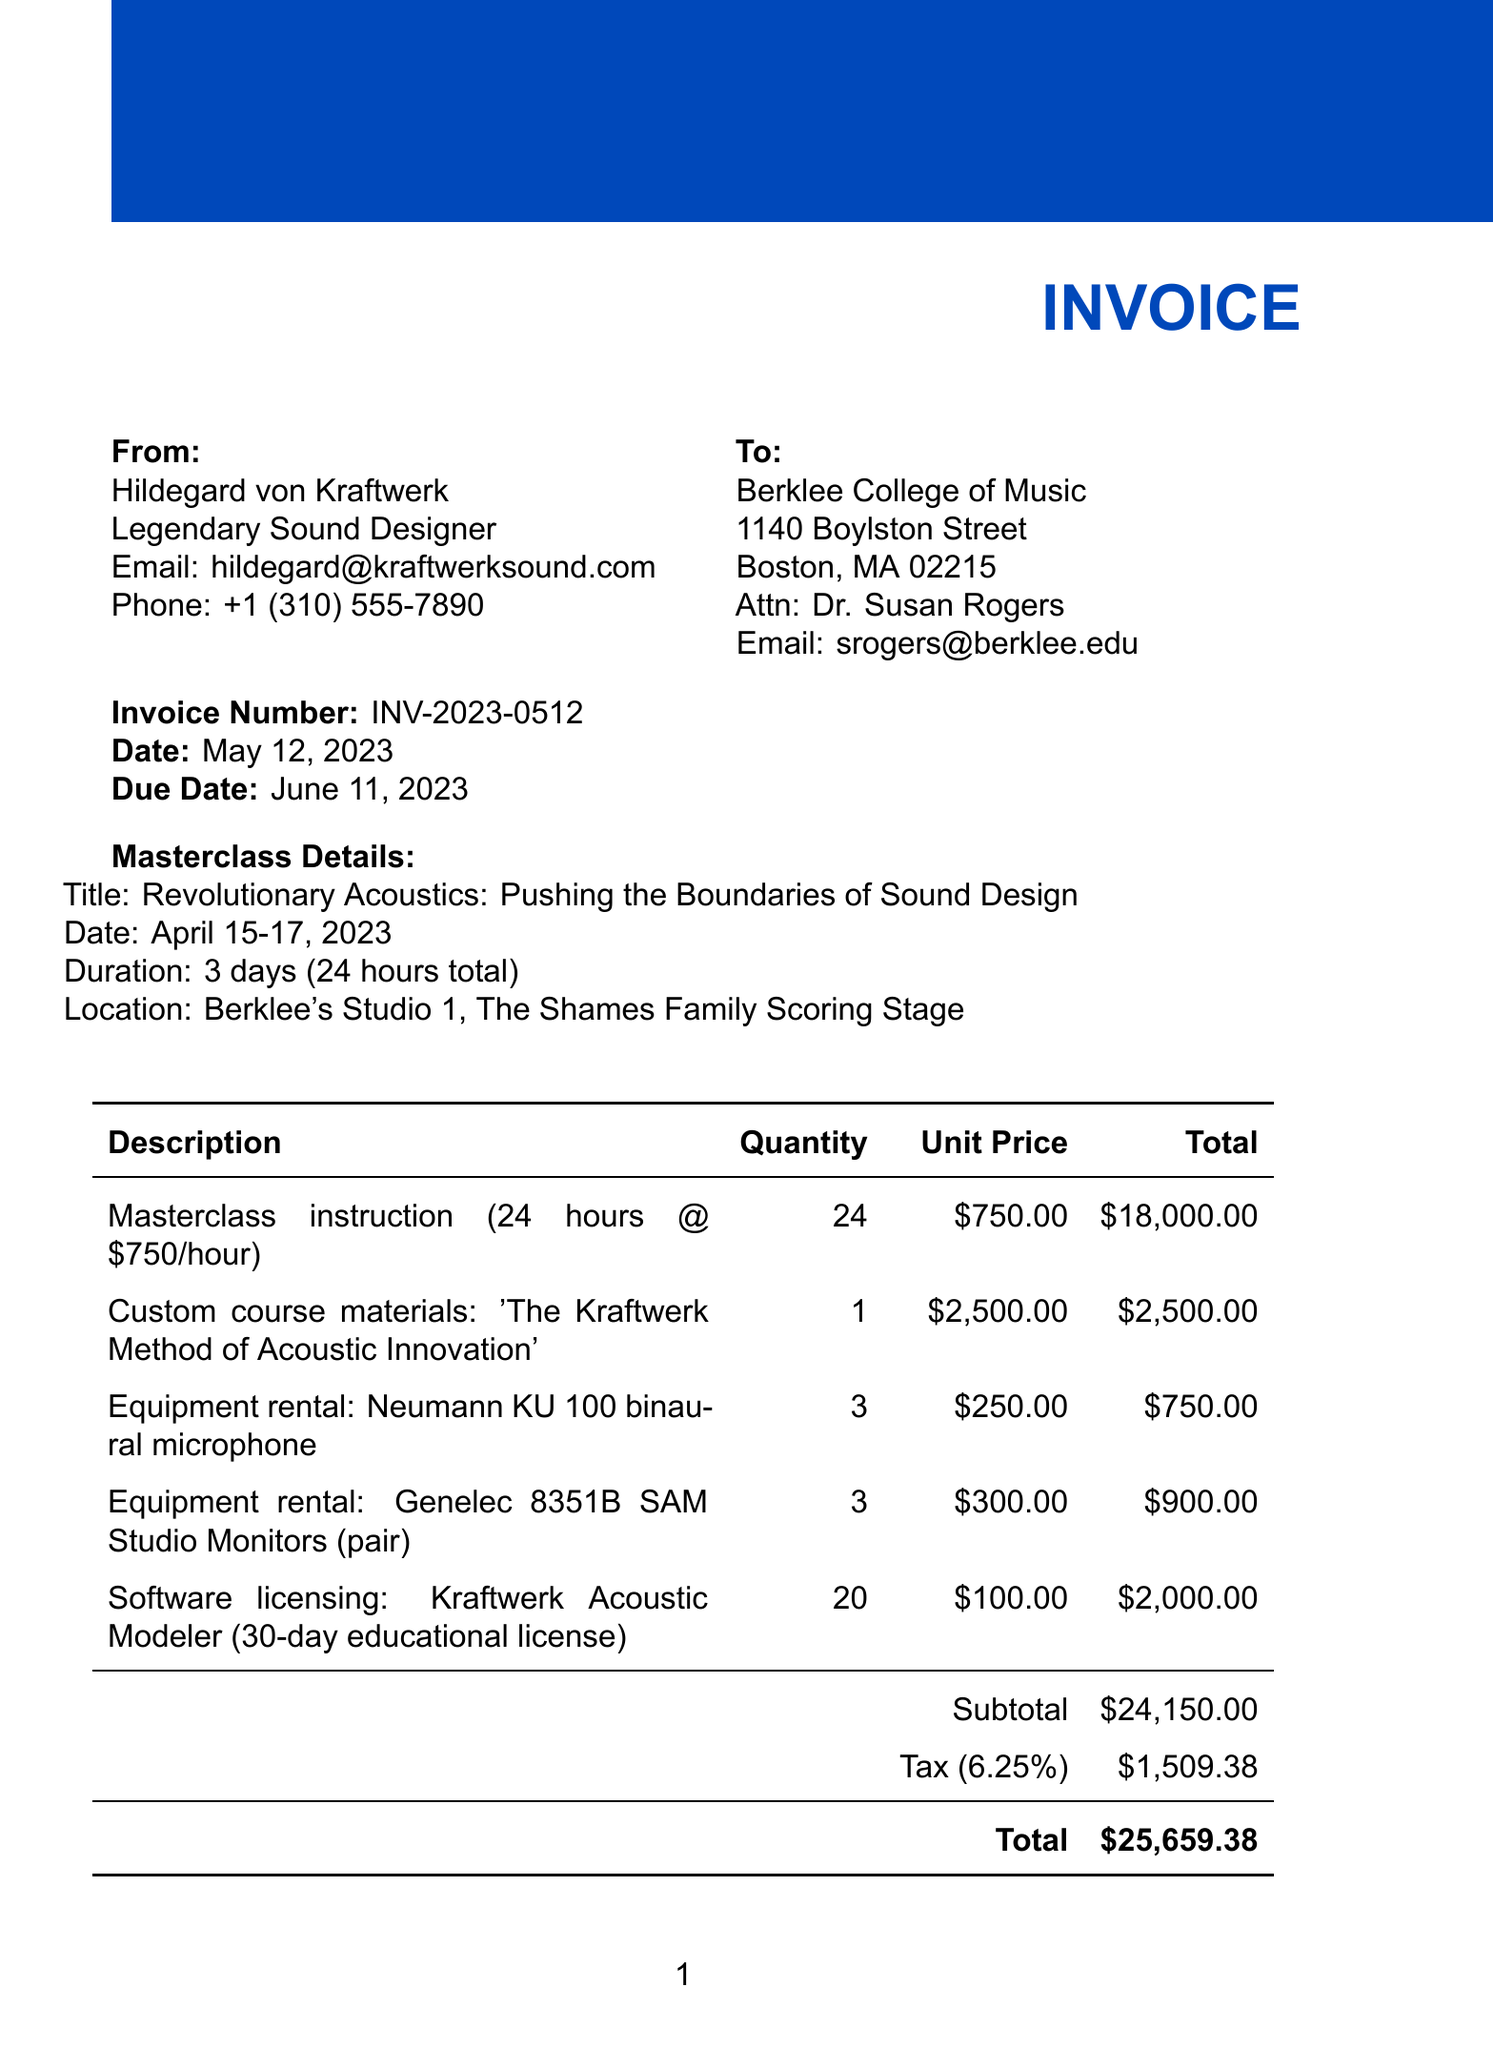What is the invoice number? The invoice number is explicitly mentioned in the document for easy reference.
Answer: INV-2023-0512 What is the total amount due? The total amount due is computed from the subtotal, tax, and other charges outlined in the document.
Answer: $25,659.38 Who is the contact person at Berklee College of Music? The document specifies the contact person for communication regarding the invoice.
Answer: Dr. Susan Rogers What is the duration of the masterclass? The duration of the masterclass is detailed in the masterclass section of the document.
Answer: 3 days (24 hours total) What was the quantity of 'Kraftwerk Acoustic Modeler' licenses? The number of software licenses requested is listed in the line items of the invoice.
Answer: 20 When was the masterclass conducted? The date of the masterclass is clearly stated to provide context for the service rendered.
Answer: April 15-17, 2023 What is the payment term specified in the invoice? Payment terms are outlined in the additional info section to guide payment processing.
Answer: Net 30 How much was charged for custom course materials? The cost for custom course materials is specified in the line items to track individual charges.
Answer: $2,500.00 What is the due date for the invoice? The document states the due date to inform the client when payment is expected.
Answer: June 11, 2023 